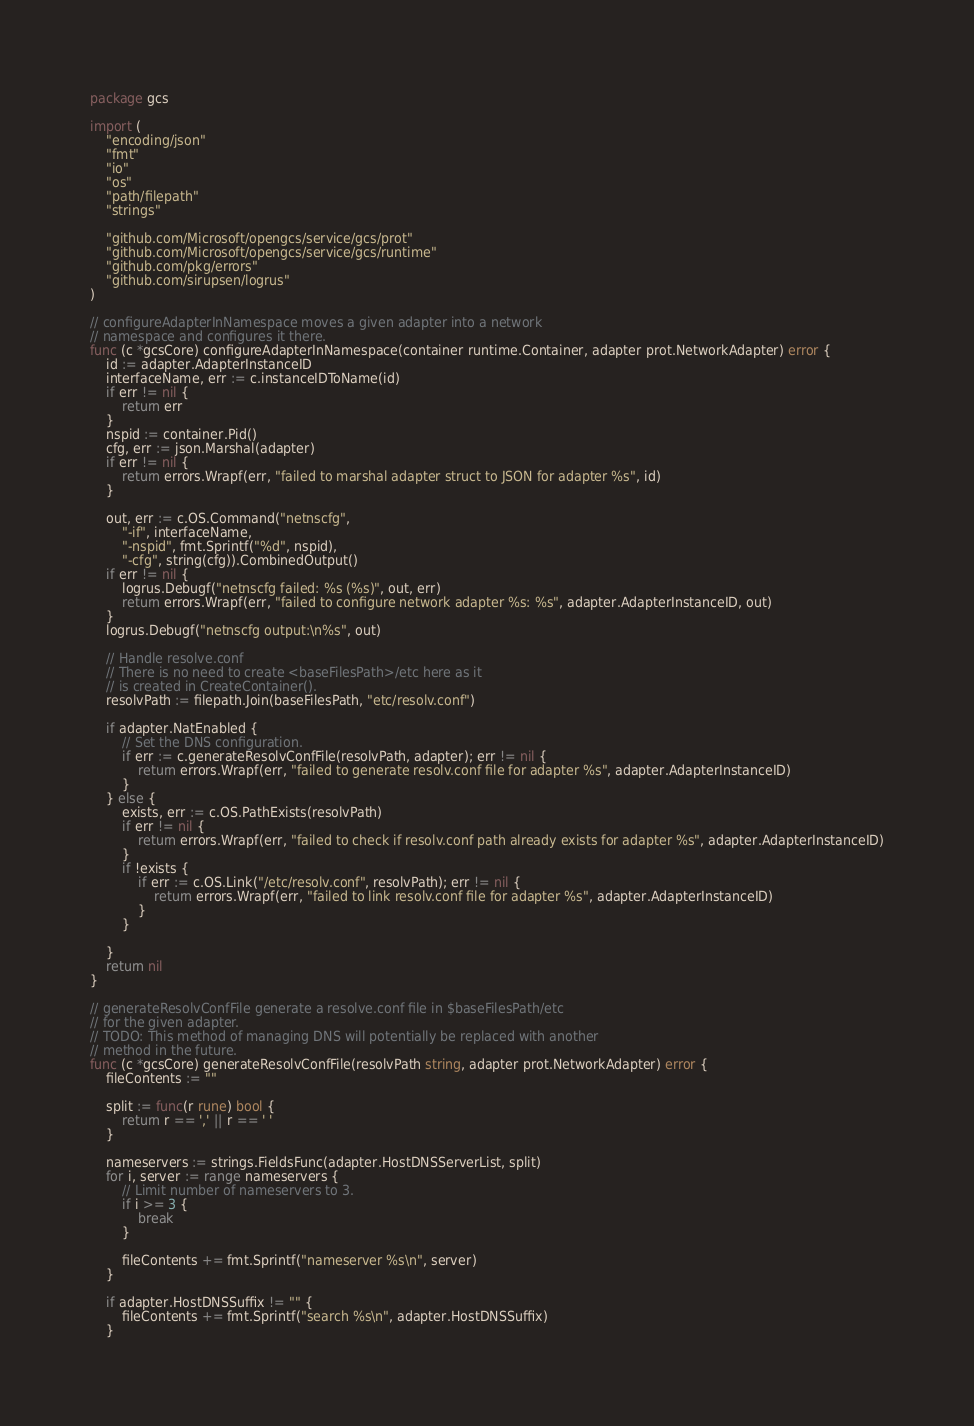<code> <loc_0><loc_0><loc_500><loc_500><_Go_>package gcs

import (
	"encoding/json"
	"fmt"
	"io"
	"os"
	"path/filepath"
	"strings"

	"github.com/Microsoft/opengcs/service/gcs/prot"
	"github.com/Microsoft/opengcs/service/gcs/runtime"
	"github.com/pkg/errors"
	"github.com/sirupsen/logrus"
)

// configureAdapterInNamespace moves a given adapter into a network
// namespace and configures it there.
func (c *gcsCore) configureAdapterInNamespace(container runtime.Container, adapter prot.NetworkAdapter) error {
	id := adapter.AdapterInstanceID
	interfaceName, err := c.instanceIDToName(id)
	if err != nil {
		return err
	}
	nspid := container.Pid()
	cfg, err := json.Marshal(adapter)
	if err != nil {
		return errors.Wrapf(err, "failed to marshal adapter struct to JSON for adapter %s", id)
	}

	out, err := c.OS.Command("netnscfg",
		"-if", interfaceName,
		"-nspid", fmt.Sprintf("%d", nspid),
		"-cfg", string(cfg)).CombinedOutput()
	if err != nil {
		logrus.Debugf("netnscfg failed: %s (%s)", out, err)
		return errors.Wrapf(err, "failed to configure network adapter %s: %s", adapter.AdapterInstanceID, out)
	}
	logrus.Debugf("netnscfg output:\n%s", out)

	// Handle resolve.conf
	// There is no need to create <baseFilesPath>/etc here as it
	// is created in CreateContainer().
	resolvPath := filepath.Join(baseFilesPath, "etc/resolv.conf")

	if adapter.NatEnabled {
		// Set the DNS configuration.
		if err := c.generateResolvConfFile(resolvPath, adapter); err != nil {
			return errors.Wrapf(err, "failed to generate resolv.conf file for adapter %s", adapter.AdapterInstanceID)
		}
	} else {
		exists, err := c.OS.PathExists(resolvPath)
		if err != nil {
			return errors.Wrapf(err, "failed to check if resolv.conf path already exists for adapter %s", adapter.AdapterInstanceID)
		}
		if !exists {
			if err := c.OS.Link("/etc/resolv.conf", resolvPath); err != nil {
				return errors.Wrapf(err, "failed to link resolv.conf file for adapter %s", adapter.AdapterInstanceID)
			}
		}

	}
	return nil
}

// generateResolvConfFile generate a resolve.conf file in $baseFilesPath/etc
// for the given adapter.
// TODO: This method of managing DNS will potentially be replaced with another
// method in the future.
func (c *gcsCore) generateResolvConfFile(resolvPath string, adapter prot.NetworkAdapter) error {
	fileContents := ""

	split := func(r rune) bool {
		return r == ',' || r == ' '
	}

	nameservers := strings.FieldsFunc(adapter.HostDNSServerList, split)
	for i, server := range nameservers {
		// Limit number of nameservers to 3.
		if i >= 3 {
			break
		}

		fileContents += fmt.Sprintf("nameserver %s\n", server)
	}

	if adapter.HostDNSSuffix != "" {
		fileContents += fmt.Sprintf("search %s\n", adapter.HostDNSSuffix)
	}
</code> 